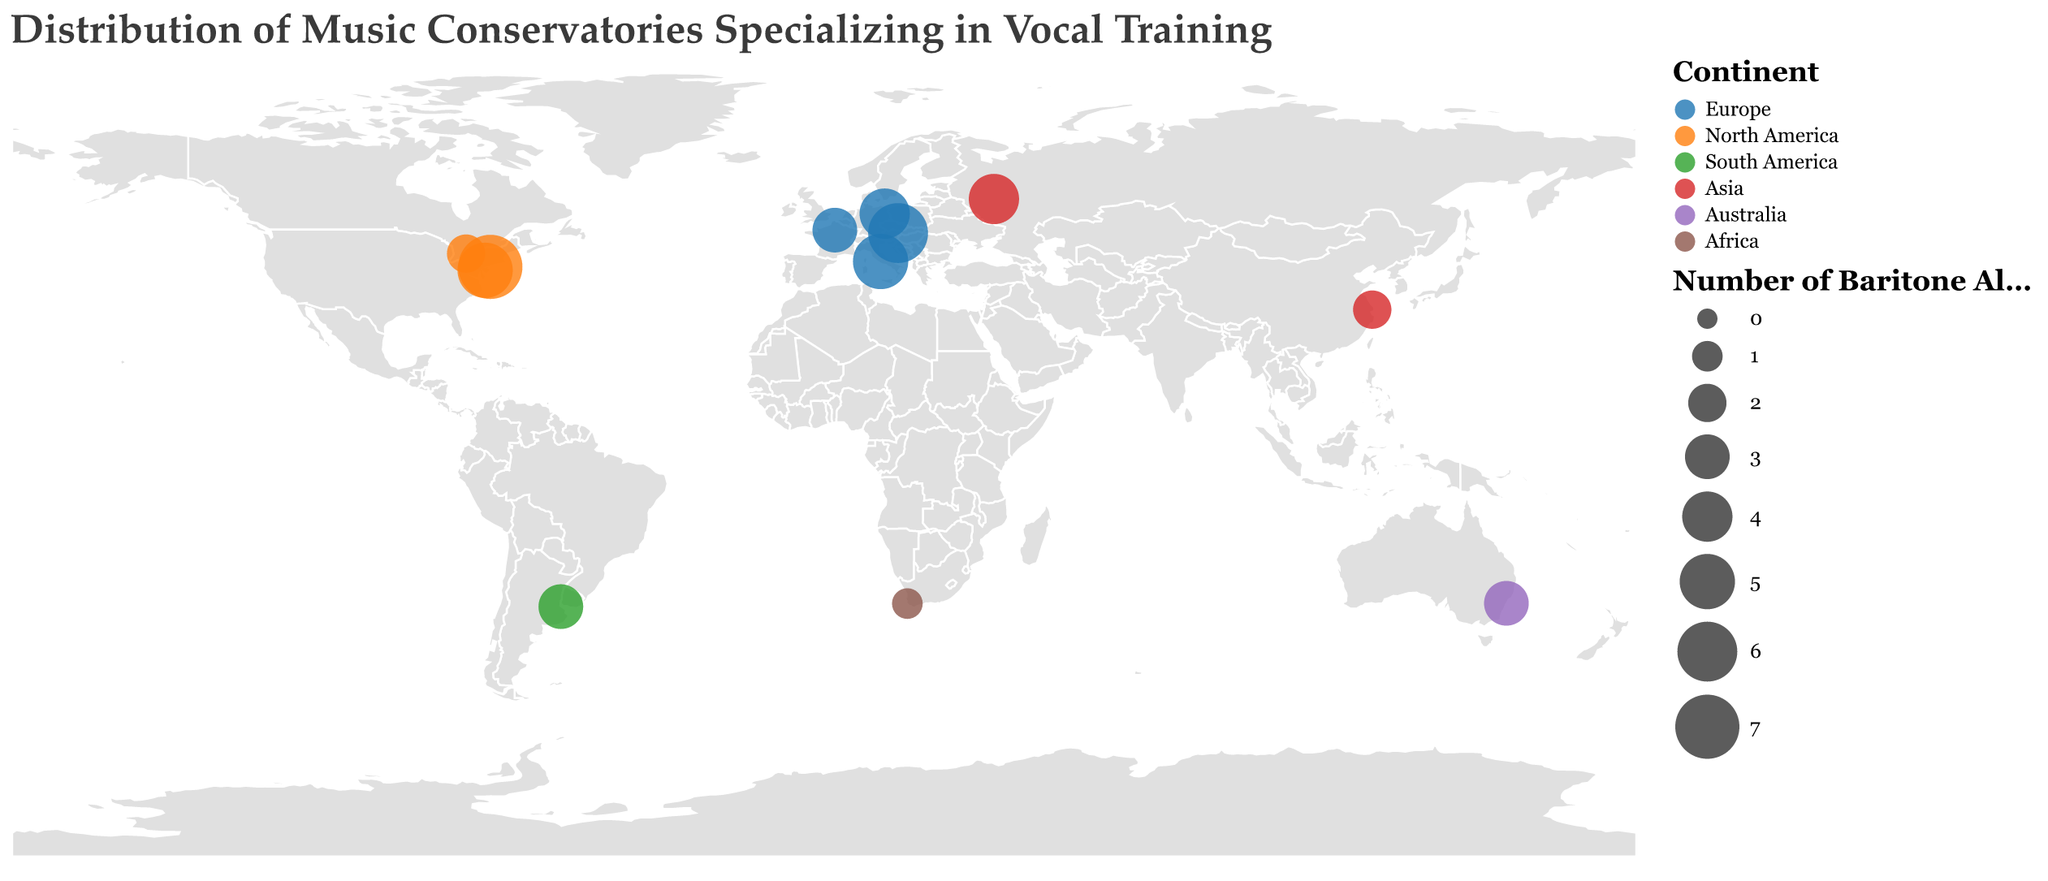How many continents are represented in the plot? Look at the legend, which shows different colors for each continent. Count the unique continents listed in the legend.
Answer: 6 Which conservatory has the largest number of baritone alumni? Refer to the size of the circles in the plot. The largest circle represents the conservatory with the highest number of baritone alumni, which is also indicated by the highest value in the tooltip.
Answer: The Juilliard School How many conservatories are there in Europe? Identify the circles with colors corresponding to Europe in the legend. Count these circles to determine the number of conservatories.
Answer: 4 Which continent has the fewest baritone alumni from its conservatories combined? Sum the "Baritone Alumni" values for each continent by looking at the respective colored circles and adding their values from the tooltips. Compare these sums across continents to find the smallest total.
Answer: Africa Which North American conservatory has the least number of baritone alumni? Look at the circles representing North American conservatories, refer to the tooltips for their baritone alumni counts, and identify the smallest number.
Answer: The Glenn Gould School What is the total number of baritone alumni from conservatories in Asia? Locate the circles representing Asian conservatories and sum their baritone alumni counts as shown in the tooltips.
Answer: 6 Compare the number of baritone alumni from conservatories in Australia and South America. Which has more? Check the "Baritone Alumni" values for the conservatories in Australia and South America using the tooltips, then compare these values.
Answer: Tie (Both have 3 alumni) What is the average number of baritone alumni from European conservatories? Identify the baritone alumni counts for European conservatories from the tooltips: 5, 4, 6, 3. Sum these values and divide by the number of European conservatories.
Answer: 4.5 Which country in Europe has the highest number of baritone alumni from its conservatories? Examine the circles representing European countries and refer to the tooltips for their baritone alumni counts. Identify the country with the highest value.
Answer: Austria What is the sum of baritone alumni from conservatories in the USA? Identify the circles representing USA conservatories and sum the baritone alumni counts shown in the tooltips: 7 (The Juilliard School) + 5 (Curtis Institute of Music).
Answer: 12 